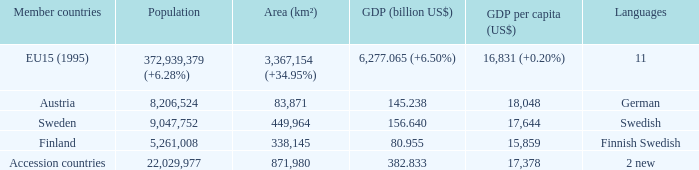Name the area for german 83871.0. 